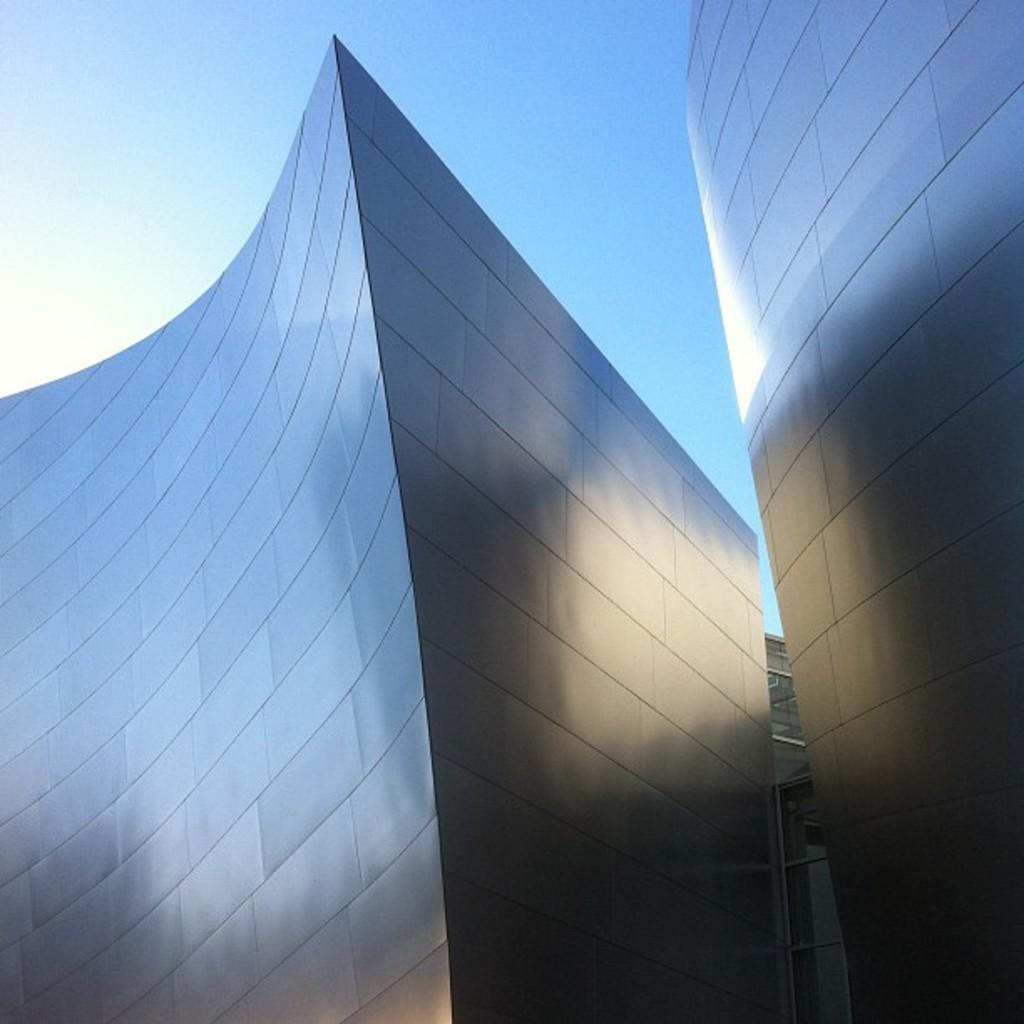What type of structures can be seen in the image? There are buildings in the image. What part of the natural environment is visible in the image? The sky is visible in the image. What can be observed in the sky? Clouds are present in the sky. Where is the throne located in the image? There is no throne present in the image. How many chickens can be seen in the image? There are no chickens present in the image. 